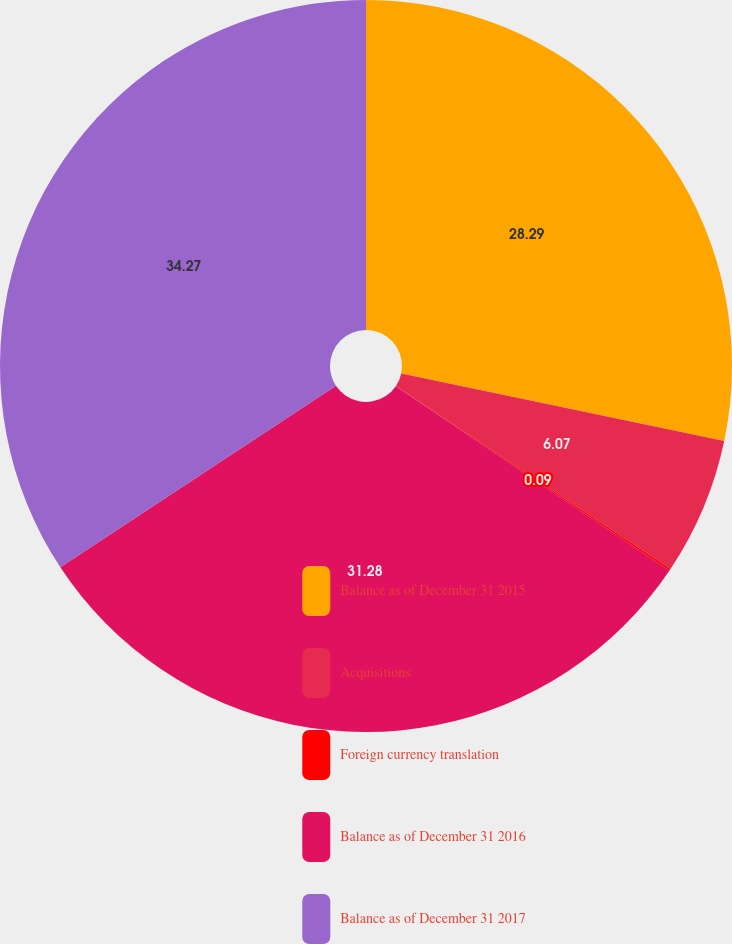<chart> <loc_0><loc_0><loc_500><loc_500><pie_chart><fcel>Balance as of December 31 2015<fcel>Acquisitions<fcel>Foreign currency translation<fcel>Balance as of December 31 2016<fcel>Balance as of December 31 2017<nl><fcel>28.29%<fcel>6.07%<fcel>0.09%<fcel>31.28%<fcel>34.27%<nl></chart> 